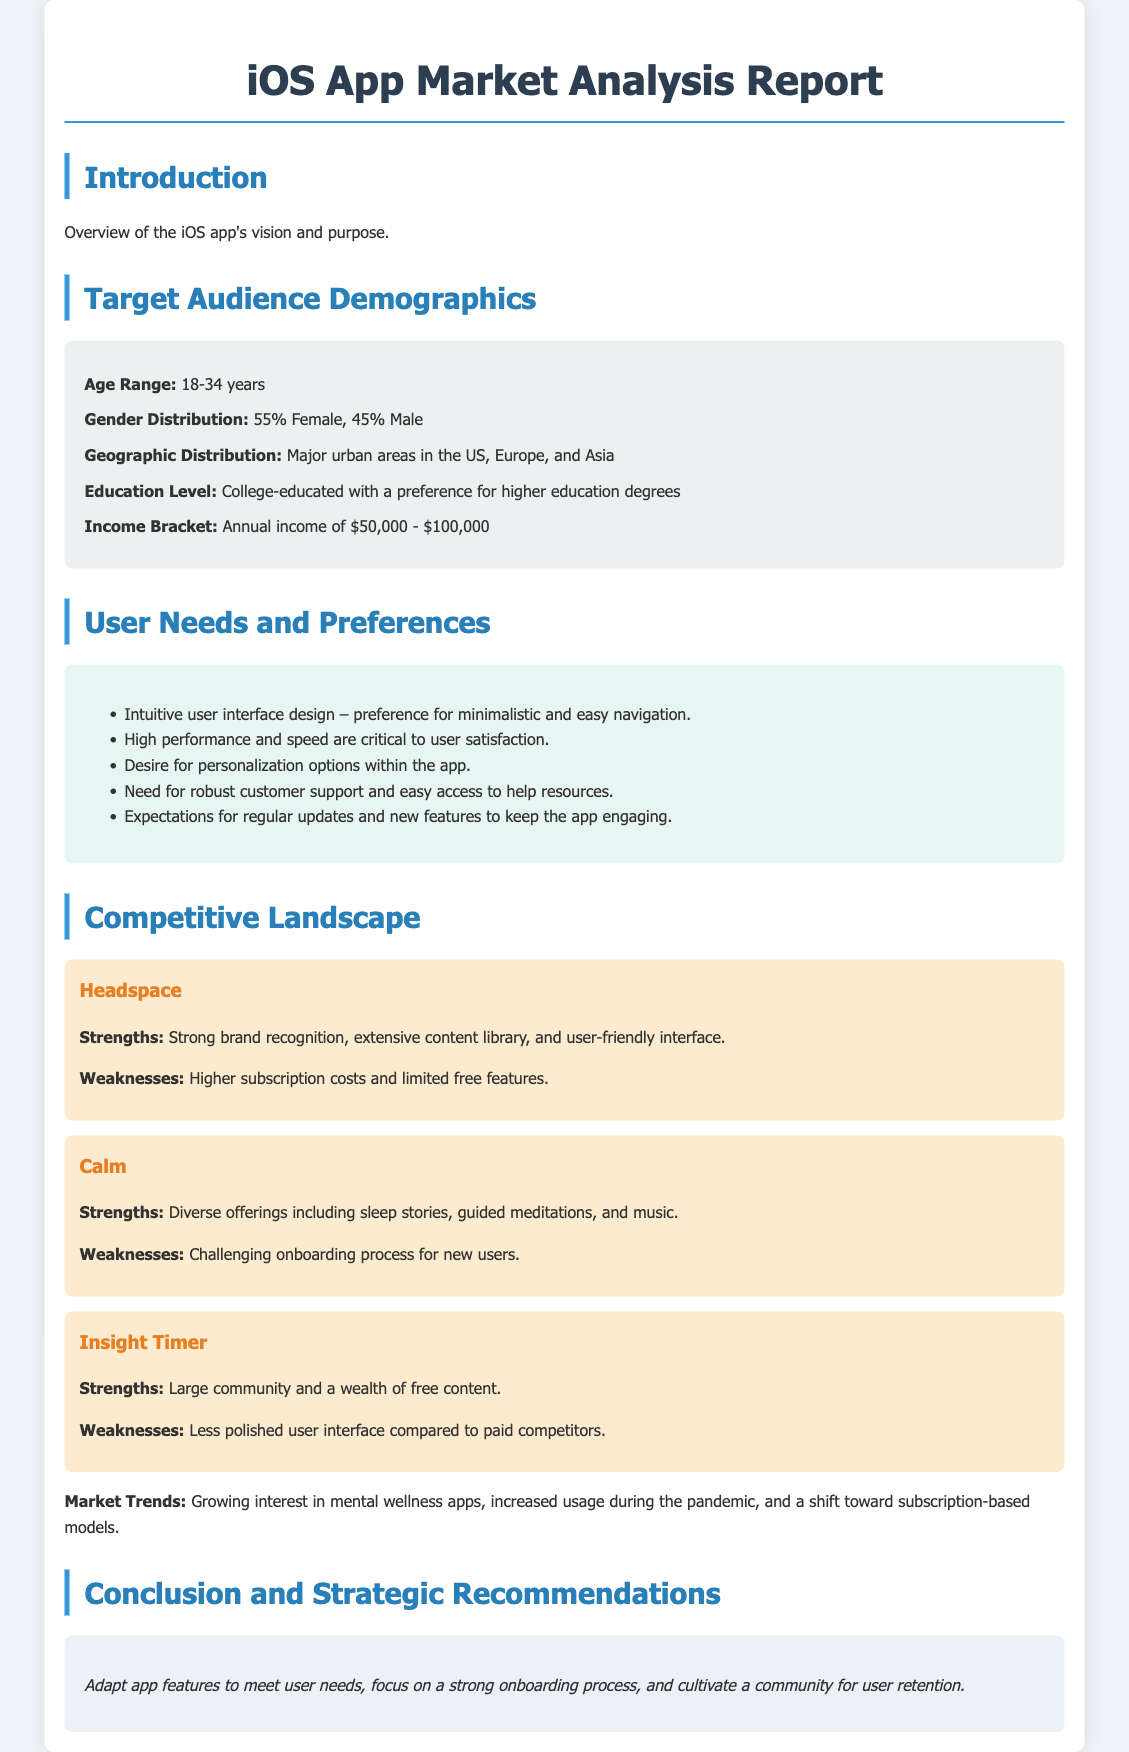what is the age range of the target audience? The age range of the target audience is specified in the demographics section.
Answer: 18-34 years what is the gender distribution of users? The gender distribution is provided in the demographics section.
Answer: 55% Female, 45% Male what is a key user need regarding app design? The user needs highlight preferences for certain design aspects.
Answer: Intuitive user interface design what is the income bracket of the target audience? The income bracket for the target audience is mentioned in the document.
Answer: Annual income of $50,000 - $100,000 who is one of the competitors mentioned in the report? The competitors are listed in the competitive landscape section.
Answer: Headspace what is a strength of the Calm app? Strengths of competitors are discussed in their respective sections.
Answer: Diverse offerings including sleep stories what is a key market trend for mental wellness apps? The document mentions trends in the market analysis section.
Answer: Growing interest in mental wellness apps what feature is important for user retention? The conclusion section includes strategic recommendations for user retention.
Answer: Cultivate a community how is the document structured? The overall structure of the document indicates the type of content it contains.
Answer: Sections divided into Introduction, Demographics, User Needs, Competitive Landscape, and Conclusion 